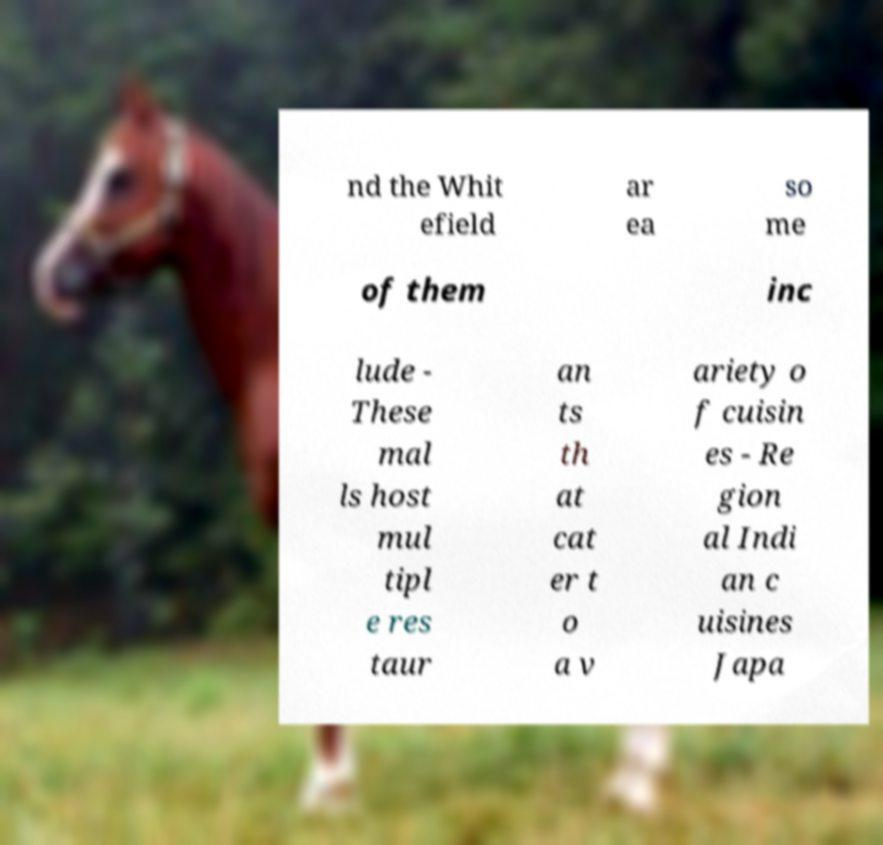Can you read and provide the text displayed in the image?This photo seems to have some interesting text. Can you extract and type it out for me? nd the Whit efield ar ea so me of them inc lude - These mal ls host mul tipl e res taur an ts th at cat er t o a v ariety o f cuisin es - Re gion al Indi an c uisines Japa 